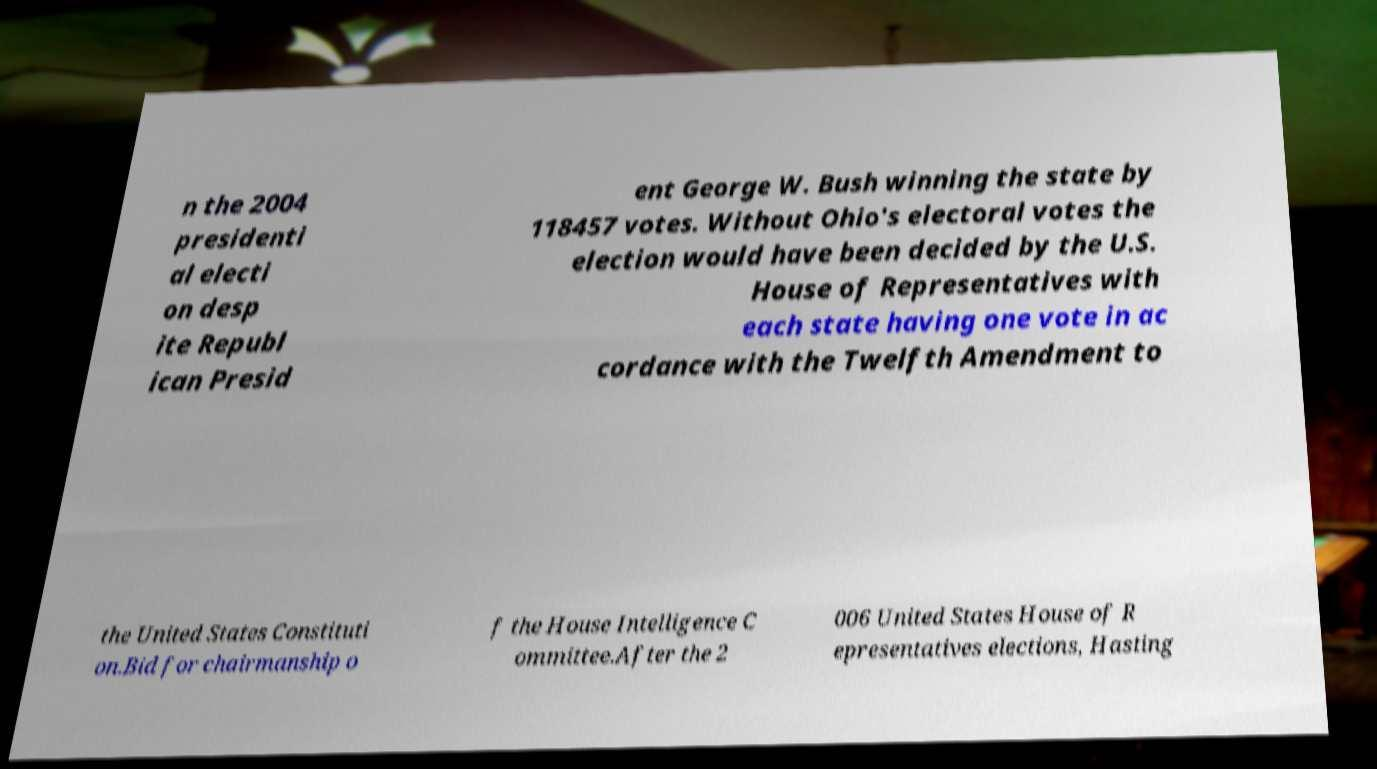Could you extract and type out the text from this image? n the 2004 presidenti al electi on desp ite Republ ican Presid ent George W. Bush winning the state by 118457 votes. Without Ohio's electoral votes the election would have been decided by the U.S. House of Representatives with each state having one vote in ac cordance with the Twelfth Amendment to the United States Constituti on.Bid for chairmanship o f the House Intelligence C ommittee.After the 2 006 United States House of R epresentatives elections, Hasting 